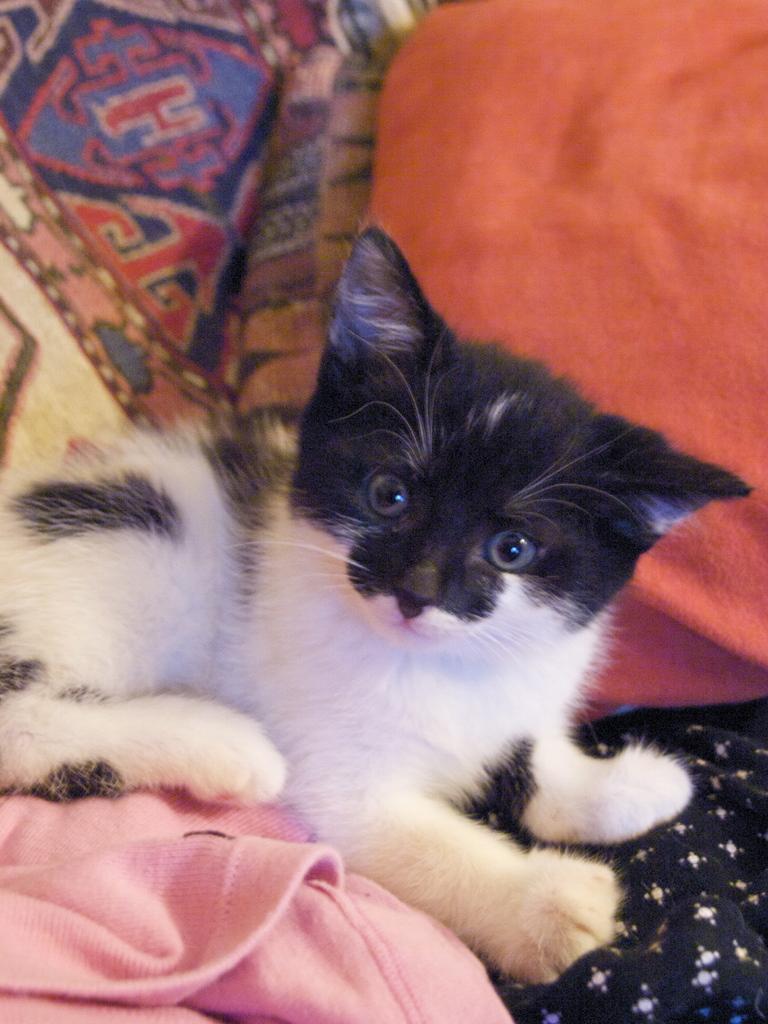Describe this image in one or two sentences. In this picture we can see a cat laying here, we can see clothes in the background. 